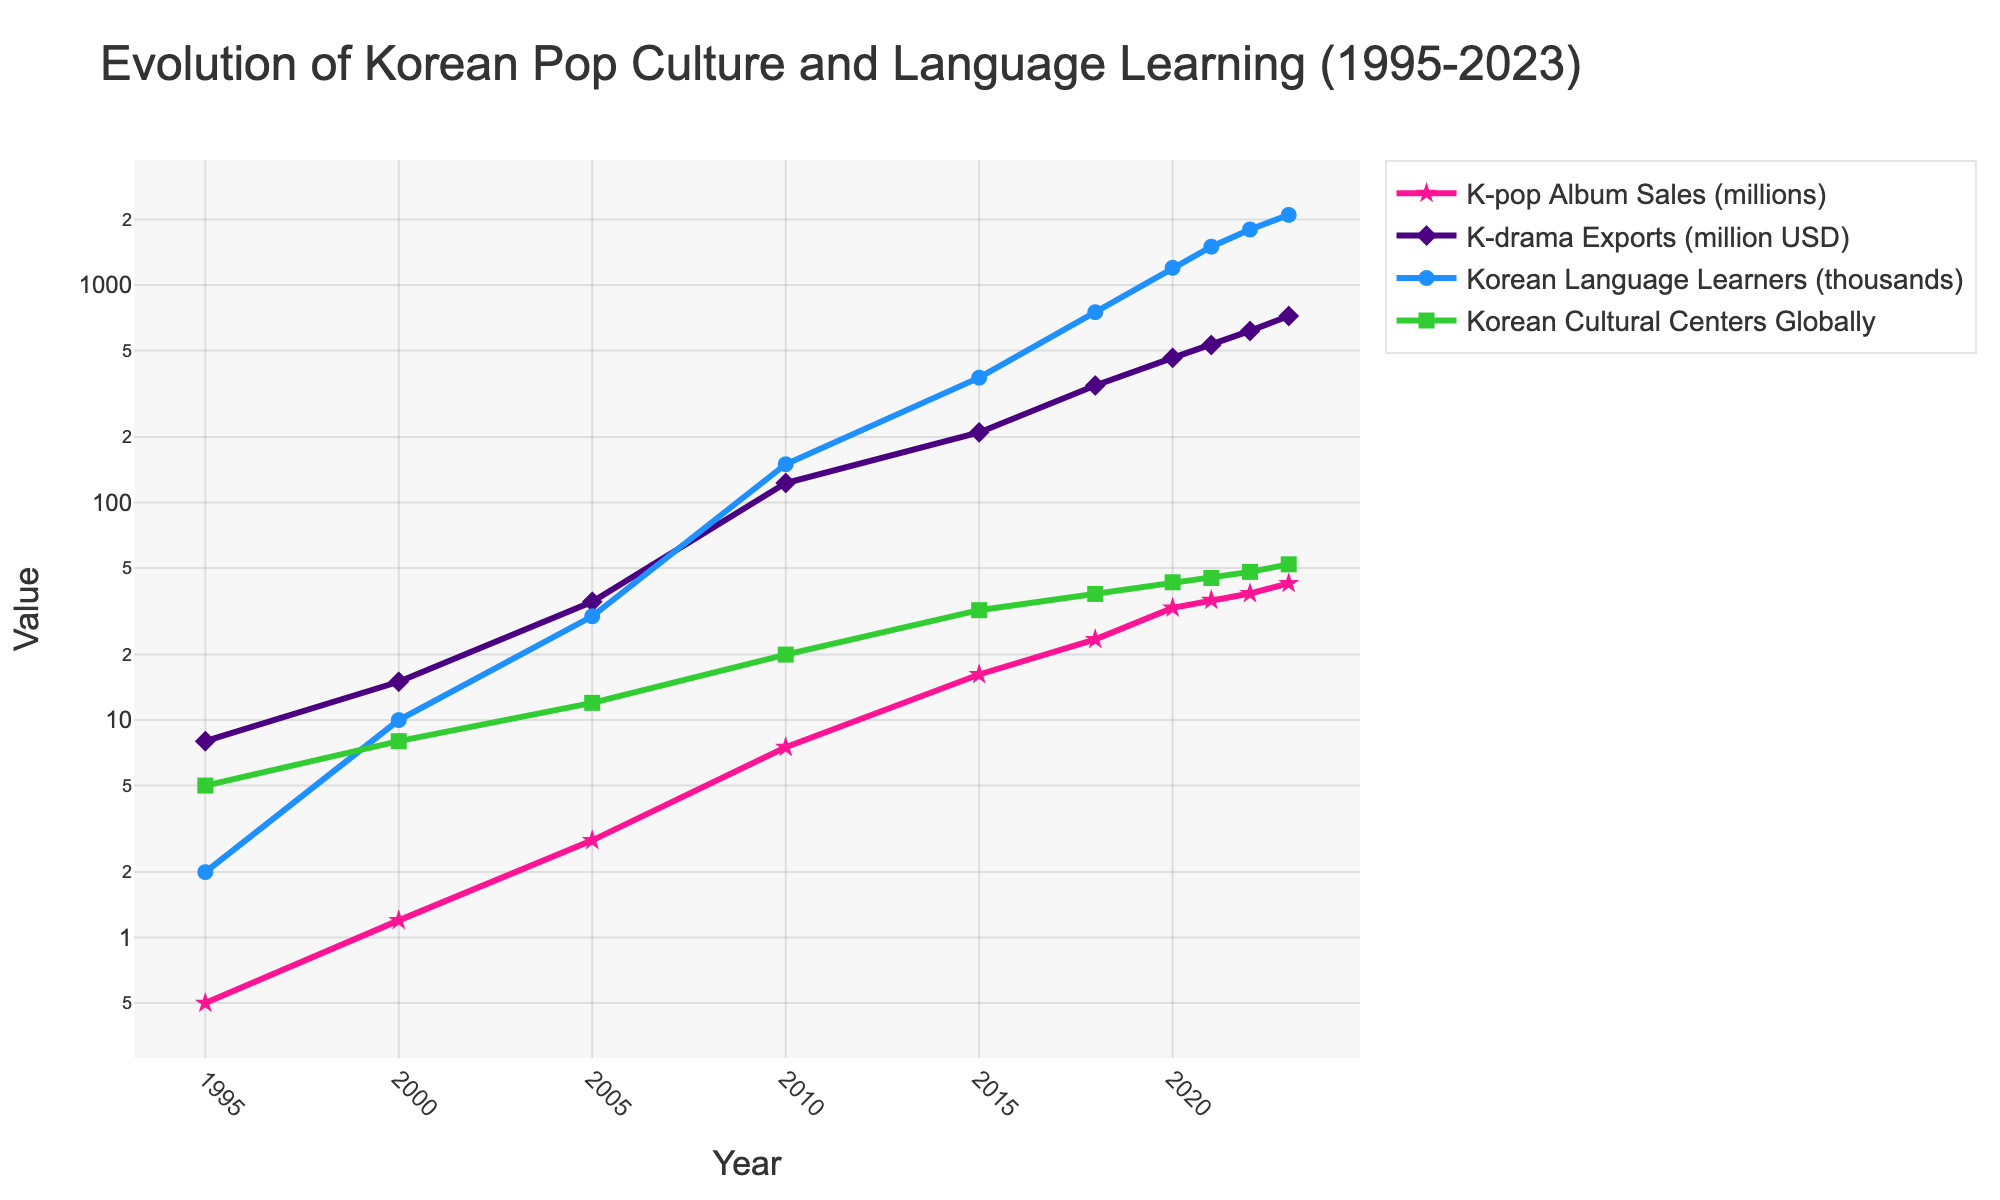What was the total K-pop album sales in millions for the years 1995 and 2023? To find the total K-pop album sales for the years 1995 and 2023, add the values for these years (0.5 million in 1995 and 42.5 million in 2023). Sum them up: 0.5 + 42.5 = 43.0 million
Answer: 43.0 million By how much did K-drama exports grow from 2005 to 2023? Subtract the K-drama exports value in 2005 from the value in 2023 (720 million USD in 2023 and 35 million USD in 2005). The difference is 720 - 35 = 685 million USD
Answer: 685 million USD Which year had the highest number of Korean cultural centers globally, and how many were there in that year? The year with the highest number of Korean cultural centers is 2023 with 52 centers. This information can be directly observed from the line corresponding to Korean cultural centers globally.
Answer: 2023, 52 centers Compare the number of Korean language learners worldwide between the years 2010 and 2022. Which year had more learners and by how much? From the chart, the number of Korean language learners worldwide in 2010 was 150,000, and in 2022 it was 1,800,000. Subtract the 2010 value from the 2022 value to find the difference: 1,800,000 - 150,000 = 1,650,000. 2022 had more learners.
Answer: 2022 had 1,650,000 more learners What is the average K-pop album sales from 2000 to 2023? Calculate the average by summing the K-pop album sales from 2000 (1.2), 2005 (2.8), 2010 (7.5), 2015 (16.2), 2018 (23.5), 2020 (32.8), 2021 (35.6), 2022 (38.2), and 2023 (42.5) and divide by the number of years (9). The sum is 1.2 + 2.8 + 7.5 + 16.2 + 23.5 + 32.8 + 35.6 + 38.2 + 42.5 = 200.3. Now divide by 9: 200.3 / 9 ≈ 22.26
Answer: 22.26 million In which year did the number of Korean language learners worldwide first exceed 1 million? According to the plot, the number of Korean language learners worldwide first exceeded 1 million in 2020, with a value of 1,200,000.
Answer: 2020 Which trend showed the highest growth rate between 2015 and 2023, and what visual attribute confirms this? To identify the trend with the highest growth rate, observe the steepest upward slope between 2015 and 2023. The K-drama Exports (million USD) line (colored purple) shows the steepest slope, indicating the highest growth rate in this period.
Answer: K-drama Exports, purple line How many more Korean cultural centers were there globally in 2023 compared to 1995? Subtract the number of Korean cultural centers globally in 1995 from the number in 2023 (52 centers in 2023 minus 5 centers in 1995). The difference is 52 - 5 = 47 centers.
Answer: 47 centers 